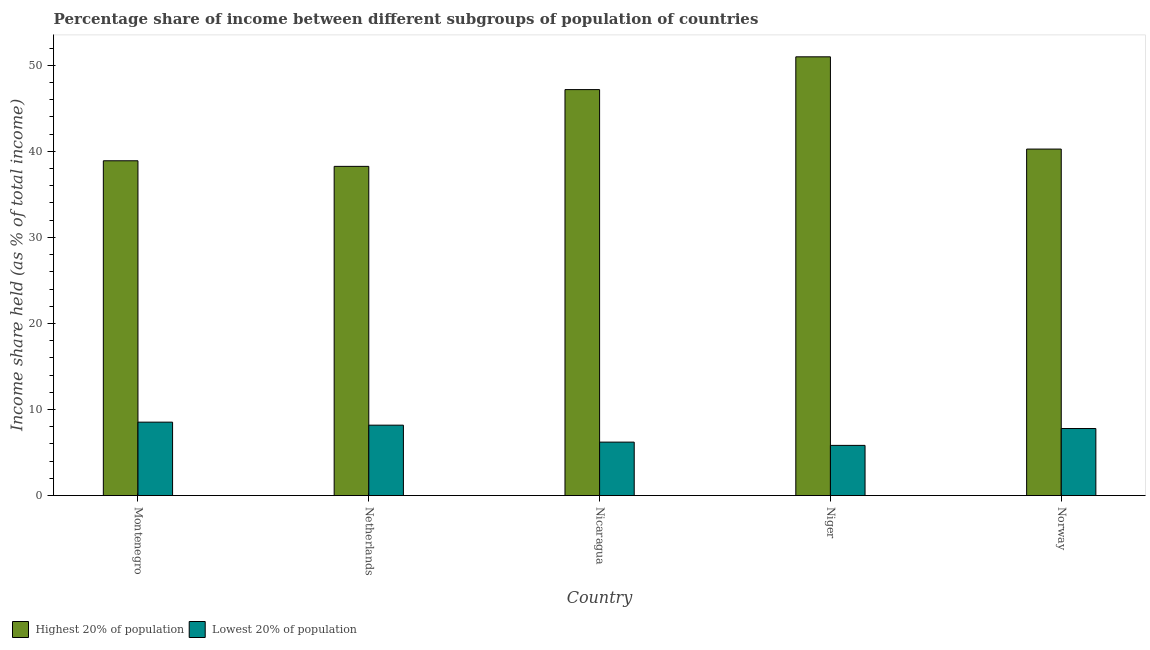How many different coloured bars are there?
Offer a very short reply. 2. Are the number of bars per tick equal to the number of legend labels?
Keep it short and to the point. Yes. How many bars are there on the 4th tick from the left?
Offer a terse response. 2. What is the label of the 4th group of bars from the left?
Your response must be concise. Niger. What is the income share held by lowest 20% of the population in Netherlands?
Make the answer very short. 8.18. Across all countries, what is the maximum income share held by lowest 20% of the population?
Your response must be concise. 8.53. Across all countries, what is the minimum income share held by lowest 20% of the population?
Offer a very short reply. 5.83. In which country was the income share held by lowest 20% of the population maximum?
Your answer should be very brief. Montenegro. What is the total income share held by lowest 20% of the population in the graph?
Ensure brevity in your answer.  36.54. What is the difference between the income share held by lowest 20% of the population in Montenegro and that in Nicaragua?
Keep it short and to the point. 2.32. What is the difference between the income share held by highest 20% of the population in Netherlands and the income share held by lowest 20% of the population in Montenegro?
Keep it short and to the point. 29.72. What is the average income share held by lowest 20% of the population per country?
Ensure brevity in your answer.  7.31. What is the difference between the income share held by lowest 20% of the population and income share held by highest 20% of the population in Norway?
Make the answer very short. -32.47. What is the ratio of the income share held by highest 20% of the population in Nicaragua to that in Norway?
Provide a short and direct response. 1.17. Is the income share held by highest 20% of the population in Netherlands less than that in Nicaragua?
Make the answer very short. Yes. Is the difference between the income share held by lowest 20% of the population in Netherlands and Norway greater than the difference between the income share held by highest 20% of the population in Netherlands and Norway?
Offer a terse response. Yes. What is the difference between the highest and the second highest income share held by highest 20% of the population?
Keep it short and to the point. 3.81. What is the difference between the highest and the lowest income share held by highest 20% of the population?
Provide a succinct answer. 12.73. In how many countries, is the income share held by lowest 20% of the population greater than the average income share held by lowest 20% of the population taken over all countries?
Provide a short and direct response. 3. Is the sum of the income share held by highest 20% of the population in Montenegro and Niger greater than the maximum income share held by lowest 20% of the population across all countries?
Offer a very short reply. Yes. What does the 2nd bar from the left in Netherlands represents?
Your response must be concise. Lowest 20% of population. What does the 1st bar from the right in Norway represents?
Provide a succinct answer. Lowest 20% of population. How many bars are there?
Your response must be concise. 10. Does the graph contain any zero values?
Your answer should be compact. No. How many legend labels are there?
Make the answer very short. 2. How are the legend labels stacked?
Your answer should be very brief. Horizontal. What is the title of the graph?
Your response must be concise. Percentage share of income between different subgroups of population of countries. Does "Highest 20% of population" appear as one of the legend labels in the graph?
Your response must be concise. Yes. What is the label or title of the X-axis?
Provide a succinct answer. Country. What is the label or title of the Y-axis?
Provide a short and direct response. Income share held (as % of total income). What is the Income share held (as % of total income) in Highest 20% of population in Montenegro?
Make the answer very short. 38.9. What is the Income share held (as % of total income) of Lowest 20% of population in Montenegro?
Offer a very short reply. 8.53. What is the Income share held (as % of total income) of Highest 20% of population in Netherlands?
Ensure brevity in your answer.  38.25. What is the Income share held (as % of total income) of Lowest 20% of population in Netherlands?
Your response must be concise. 8.18. What is the Income share held (as % of total income) in Highest 20% of population in Nicaragua?
Your answer should be very brief. 47.17. What is the Income share held (as % of total income) of Lowest 20% of population in Nicaragua?
Your answer should be compact. 6.21. What is the Income share held (as % of total income) of Highest 20% of population in Niger?
Offer a very short reply. 50.98. What is the Income share held (as % of total income) of Lowest 20% of population in Niger?
Make the answer very short. 5.83. What is the Income share held (as % of total income) in Highest 20% of population in Norway?
Keep it short and to the point. 40.26. What is the Income share held (as % of total income) in Lowest 20% of population in Norway?
Your answer should be very brief. 7.79. Across all countries, what is the maximum Income share held (as % of total income) in Highest 20% of population?
Keep it short and to the point. 50.98. Across all countries, what is the maximum Income share held (as % of total income) of Lowest 20% of population?
Your answer should be compact. 8.53. Across all countries, what is the minimum Income share held (as % of total income) in Highest 20% of population?
Offer a terse response. 38.25. Across all countries, what is the minimum Income share held (as % of total income) of Lowest 20% of population?
Offer a terse response. 5.83. What is the total Income share held (as % of total income) of Highest 20% of population in the graph?
Offer a terse response. 215.56. What is the total Income share held (as % of total income) in Lowest 20% of population in the graph?
Your answer should be very brief. 36.54. What is the difference between the Income share held (as % of total income) in Highest 20% of population in Montenegro and that in Netherlands?
Provide a short and direct response. 0.65. What is the difference between the Income share held (as % of total income) of Highest 20% of population in Montenegro and that in Nicaragua?
Provide a short and direct response. -8.27. What is the difference between the Income share held (as % of total income) of Lowest 20% of population in Montenegro and that in Nicaragua?
Keep it short and to the point. 2.32. What is the difference between the Income share held (as % of total income) of Highest 20% of population in Montenegro and that in Niger?
Offer a terse response. -12.08. What is the difference between the Income share held (as % of total income) in Highest 20% of population in Montenegro and that in Norway?
Give a very brief answer. -1.36. What is the difference between the Income share held (as % of total income) in Lowest 20% of population in Montenegro and that in Norway?
Make the answer very short. 0.74. What is the difference between the Income share held (as % of total income) in Highest 20% of population in Netherlands and that in Nicaragua?
Provide a succinct answer. -8.92. What is the difference between the Income share held (as % of total income) of Lowest 20% of population in Netherlands and that in Nicaragua?
Your answer should be very brief. 1.97. What is the difference between the Income share held (as % of total income) of Highest 20% of population in Netherlands and that in Niger?
Your response must be concise. -12.73. What is the difference between the Income share held (as % of total income) of Lowest 20% of population in Netherlands and that in Niger?
Offer a terse response. 2.35. What is the difference between the Income share held (as % of total income) in Highest 20% of population in Netherlands and that in Norway?
Make the answer very short. -2.01. What is the difference between the Income share held (as % of total income) of Lowest 20% of population in Netherlands and that in Norway?
Provide a short and direct response. 0.39. What is the difference between the Income share held (as % of total income) of Highest 20% of population in Nicaragua and that in Niger?
Your answer should be compact. -3.81. What is the difference between the Income share held (as % of total income) in Lowest 20% of population in Nicaragua and that in Niger?
Offer a very short reply. 0.38. What is the difference between the Income share held (as % of total income) in Highest 20% of population in Nicaragua and that in Norway?
Your answer should be compact. 6.91. What is the difference between the Income share held (as % of total income) of Lowest 20% of population in Nicaragua and that in Norway?
Provide a succinct answer. -1.58. What is the difference between the Income share held (as % of total income) in Highest 20% of population in Niger and that in Norway?
Offer a very short reply. 10.72. What is the difference between the Income share held (as % of total income) of Lowest 20% of population in Niger and that in Norway?
Offer a terse response. -1.96. What is the difference between the Income share held (as % of total income) in Highest 20% of population in Montenegro and the Income share held (as % of total income) in Lowest 20% of population in Netherlands?
Offer a very short reply. 30.72. What is the difference between the Income share held (as % of total income) in Highest 20% of population in Montenegro and the Income share held (as % of total income) in Lowest 20% of population in Nicaragua?
Ensure brevity in your answer.  32.69. What is the difference between the Income share held (as % of total income) of Highest 20% of population in Montenegro and the Income share held (as % of total income) of Lowest 20% of population in Niger?
Your response must be concise. 33.07. What is the difference between the Income share held (as % of total income) in Highest 20% of population in Montenegro and the Income share held (as % of total income) in Lowest 20% of population in Norway?
Offer a terse response. 31.11. What is the difference between the Income share held (as % of total income) of Highest 20% of population in Netherlands and the Income share held (as % of total income) of Lowest 20% of population in Nicaragua?
Ensure brevity in your answer.  32.04. What is the difference between the Income share held (as % of total income) in Highest 20% of population in Netherlands and the Income share held (as % of total income) in Lowest 20% of population in Niger?
Offer a very short reply. 32.42. What is the difference between the Income share held (as % of total income) of Highest 20% of population in Netherlands and the Income share held (as % of total income) of Lowest 20% of population in Norway?
Make the answer very short. 30.46. What is the difference between the Income share held (as % of total income) of Highest 20% of population in Nicaragua and the Income share held (as % of total income) of Lowest 20% of population in Niger?
Provide a short and direct response. 41.34. What is the difference between the Income share held (as % of total income) in Highest 20% of population in Nicaragua and the Income share held (as % of total income) in Lowest 20% of population in Norway?
Offer a very short reply. 39.38. What is the difference between the Income share held (as % of total income) in Highest 20% of population in Niger and the Income share held (as % of total income) in Lowest 20% of population in Norway?
Keep it short and to the point. 43.19. What is the average Income share held (as % of total income) in Highest 20% of population per country?
Offer a very short reply. 43.11. What is the average Income share held (as % of total income) in Lowest 20% of population per country?
Ensure brevity in your answer.  7.31. What is the difference between the Income share held (as % of total income) in Highest 20% of population and Income share held (as % of total income) in Lowest 20% of population in Montenegro?
Your answer should be compact. 30.37. What is the difference between the Income share held (as % of total income) of Highest 20% of population and Income share held (as % of total income) of Lowest 20% of population in Netherlands?
Make the answer very short. 30.07. What is the difference between the Income share held (as % of total income) of Highest 20% of population and Income share held (as % of total income) of Lowest 20% of population in Nicaragua?
Make the answer very short. 40.96. What is the difference between the Income share held (as % of total income) of Highest 20% of population and Income share held (as % of total income) of Lowest 20% of population in Niger?
Offer a terse response. 45.15. What is the difference between the Income share held (as % of total income) of Highest 20% of population and Income share held (as % of total income) of Lowest 20% of population in Norway?
Ensure brevity in your answer.  32.47. What is the ratio of the Income share held (as % of total income) of Highest 20% of population in Montenegro to that in Netherlands?
Your answer should be compact. 1.02. What is the ratio of the Income share held (as % of total income) in Lowest 20% of population in Montenegro to that in Netherlands?
Your answer should be compact. 1.04. What is the ratio of the Income share held (as % of total income) of Highest 20% of population in Montenegro to that in Nicaragua?
Give a very brief answer. 0.82. What is the ratio of the Income share held (as % of total income) in Lowest 20% of population in Montenegro to that in Nicaragua?
Offer a very short reply. 1.37. What is the ratio of the Income share held (as % of total income) in Highest 20% of population in Montenegro to that in Niger?
Your response must be concise. 0.76. What is the ratio of the Income share held (as % of total income) in Lowest 20% of population in Montenegro to that in Niger?
Provide a succinct answer. 1.46. What is the ratio of the Income share held (as % of total income) of Highest 20% of population in Montenegro to that in Norway?
Offer a very short reply. 0.97. What is the ratio of the Income share held (as % of total income) in Lowest 20% of population in Montenegro to that in Norway?
Provide a short and direct response. 1.09. What is the ratio of the Income share held (as % of total income) of Highest 20% of population in Netherlands to that in Nicaragua?
Make the answer very short. 0.81. What is the ratio of the Income share held (as % of total income) of Lowest 20% of population in Netherlands to that in Nicaragua?
Your answer should be compact. 1.32. What is the ratio of the Income share held (as % of total income) in Highest 20% of population in Netherlands to that in Niger?
Offer a terse response. 0.75. What is the ratio of the Income share held (as % of total income) of Lowest 20% of population in Netherlands to that in Niger?
Offer a very short reply. 1.4. What is the ratio of the Income share held (as % of total income) of Highest 20% of population in Netherlands to that in Norway?
Keep it short and to the point. 0.95. What is the ratio of the Income share held (as % of total income) of Lowest 20% of population in Netherlands to that in Norway?
Your answer should be very brief. 1.05. What is the ratio of the Income share held (as % of total income) in Highest 20% of population in Nicaragua to that in Niger?
Your response must be concise. 0.93. What is the ratio of the Income share held (as % of total income) in Lowest 20% of population in Nicaragua to that in Niger?
Your answer should be very brief. 1.07. What is the ratio of the Income share held (as % of total income) of Highest 20% of population in Nicaragua to that in Norway?
Your answer should be very brief. 1.17. What is the ratio of the Income share held (as % of total income) in Lowest 20% of population in Nicaragua to that in Norway?
Offer a very short reply. 0.8. What is the ratio of the Income share held (as % of total income) in Highest 20% of population in Niger to that in Norway?
Provide a short and direct response. 1.27. What is the ratio of the Income share held (as % of total income) of Lowest 20% of population in Niger to that in Norway?
Provide a succinct answer. 0.75. What is the difference between the highest and the second highest Income share held (as % of total income) of Highest 20% of population?
Provide a succinct answer. 3.81. What is the difference between the highest and the second highest Income share held (as % of total income) of Lowest 20% of population?
Keep it short and to the point. 0.35. What is the difference between the highest and the lowest Income share held (as % of total income) in Highest 20% of population?
Ensure brevity in your answer.  12.73. What is the difference between the highest and the lowest Income share held (as % of total income) of Lowest 20% of population?
Offer a terse response. 2.7. 